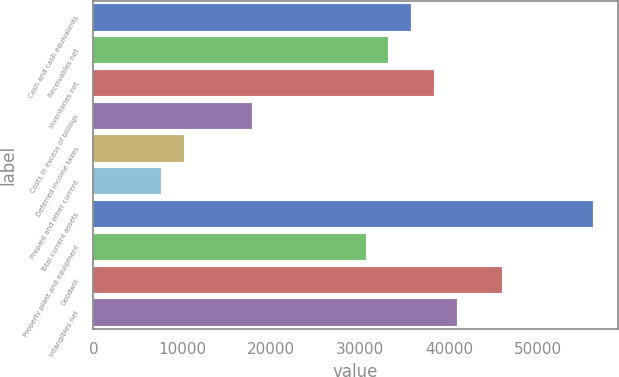Convert chart to OTSL. <chart><loc_0><loc_0><loc_500><loc_500><bar_chart><fcel>Cash and cash equivalents<fcel>Receivables net<fcel>Inventories net<fcel>Costs in excess of billings<fcel>Deferred income taxes<fcel>Prepaid and other current<fcel>Total current assets<fcel>Property plant and equipment<fcel>Goodwill<fcel>Intangibles net<nl><fcel>35719.4<fcel>33168.3<fcel>38270.5<fcel>17861.7<fcel>10208.4<fcel>7657.3<fcel>56128.2<fcel>30617.2<fcel>45923.8<fcel>40821.6<nl></chart> 